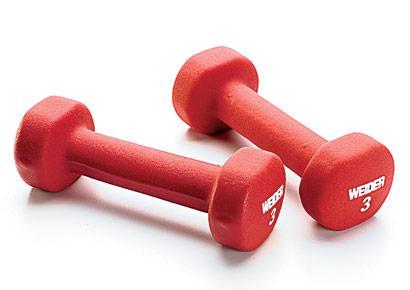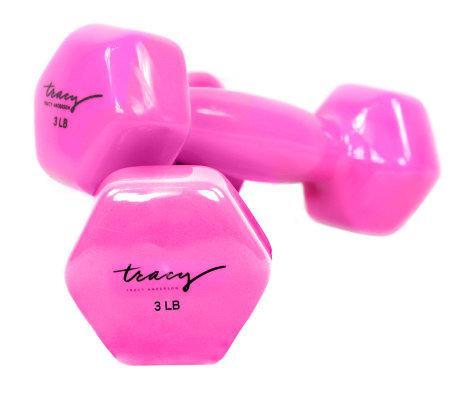The first image is the image on the left, the second image is the image on the right. Examine the images to the left and right. Is the description "The right image shows a pair of pink free weights with one weight resting slightly atop the other" accurate? Answer yes or no. Yes. The first image is the image on the left, the second image is the image on the right. Evaluate the accuracy of this statement regarding the images: "The right image contains two small pink exercise weights.". Is it true? Answer yes or no. Yes. 